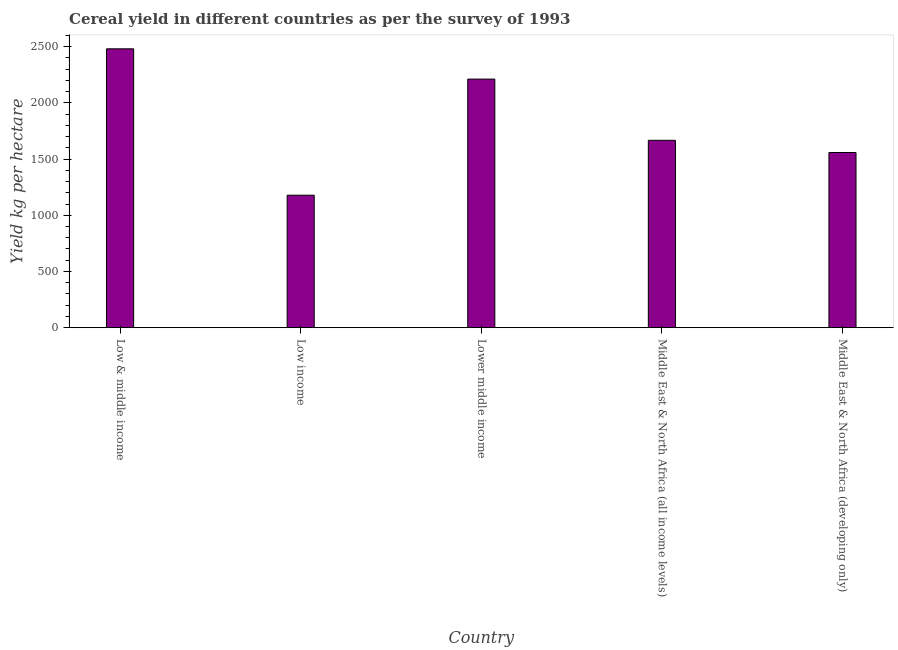What is the title of the graph?
Provide a succinct answer. Cereal yield in different countries as per the survey of 1993. What is the label or title of the X-axis?
Ensure brevity in your answer.  Country. What is the label or title of the Y-axis?
Provide a short and direct response. Yield kg per hectare. What is the cereal yield in Middle East & North Africa (all income levels)?
Ensure brevity in your answer.  1667.12. Across all countries, what is the maximum cereal yield?
Make the answer very short. 2481.08. Across all countries, what is the minimum cereal yield?
Offer a very short reply. 1178.62. What is the sum of the cereal yield?
Ensure brevity in your answer.  9097.02. What is the difference between the cereal yield in Lower middle income and Middle East & North Africa (all income levels)?
Your response must be concise. 544.64. What is the average cereal yield per country?
Offer a very short reply. 1819.4. What is the median cereal yield?
Keep it short and to the point. 1667.12. What is the ratio of the cereal yield in Lower middle income to that in Middle East & North Africa (developing only)?
Provide a short and direct response. 1.42. Is the difference between the cereal yield in Lower middle income and Middle East & North Africa (developing only) greater than the difference between any two countries?
Offer a very short reply. No. What is the difference between the highest and the second highest cereal yield?
Make the answer very short. 269.32. What is the difference between the highest and the lowest cereal yield?
Your answer should be very brief. 1302.46. In how many countries, is the cereal yield greater than the average cereal yield taken over all countries?
Keep it short and to the point. 2. Are all the bars in the graph horizontal?
Provide a succinct answer. No. What is the difference between two consecutive major ticks on the Y-axis?
Provide a succinct answer. 500. What is the Yield kg per hectare of Low & middle income?
Provide a short and direct response. 2481.08. What is the Yield kg per hectare of Low income?
Offer a terse response. 1178.62. What is the Yield kg per hectare of Lower middle income?
Ensure brevity in your answer.  2211.76. What is the Yield kg per hectare of Middle East & North Africa (all income levels)?
Your answer should be very brief. 1667.12. What is the Yield kg per hectare in Middle East & North Africa (developing only)?
Ensure brevity in your answer.  1558.43. What is the difference between the Yield kg per hectare in Low & middle income and Low income?
Offer a terse response. 1302.46. What is the difference between the Yield kg per hectare in Low & middle income and Lower middle income?
Your answer should be very brief. 269.33. What is the difference between the Yield kg per hectare in Low & middle income and Middle East & North Africa (all income levels)?
Your answer should be very brief. 813.97. What is the difference between the Yield kg per hectare in Low & middle income and Middle East & North Africa (developing only)?
Your answer should be compact. 922.65. What is the difference between the Yield kg per hectare in Low income and Lower middle income?
Your answer should be very brief. -1033.14. What is the difference between the Yield kg per hectare in Low income and Middle East & North Africa (all income levels)?
Your answer should be very brief. -488.5. What is the difference between the Yield kg per hectare in Low income and Middle East & North Africa (developing only)?
Your answer should be compact. -379.81. What is the difference between the Yield kg per hectare in Lower middle income and Middle East & North Africa (all income levels)?
Provide a succinct answer. 544.64. What is the difference between the Yield kg per hectare in Lower middle income and Middle East & North Africa (developing only)?
Make the answer very short. 653.33. What is the difference between the Yield kg per hectare in Middle East & North Africa (all income levels) and Middle East & North Africa (developing only)?
Your answer should be very brief. 108.69. What is the ratio of the Yield kg per hectare in Low & middle income to that in Low income?
Your response must be concise. 2.1. What is the ratio of the Yield kg per hectare in Low & middle income to that in Lower middle income?
Provide a short and direct response. 1.12. What is the ratio of the Yield kg per hectare in Low & middle income to that in Middle East & North Africa (all income levels)?
Your answer should be very brief. 1.49. What is the ratio of the Yield kg per hectare in Low & middle income to that in Middle East & North Africa (developing only)?
Provide a succinct answer. 1.59. What is the ratio of the Yield kg per hectare in Low income to that in Lower middle income?
Your response must be concise. 0.53. What is the ratio of the Yield kg per hectare in Low income to that in Middle East & North Africa (all income levels)?
Offer a very short reply. 0.71. What is the ratio of the Yield kg per hectare in Low income to that in Middle East & North Africa (developing only)?
Your answer should be very brief. 0.76. What is the ratio of the Yield kg per hectare in Lower middle income to that in Middle East & North Africa (all income levels)?
Make the answer very short. 1.33. What is the ratio of the Yield kg per hectare in Lower middle income to that in Middle East & North Africa (developing only)?
Provide a succinct answer. 1.42. What is the ratio of the Yield kg per hectare in Middle East & North Africa (all income levels) to that in Middle East & North Africa (developing only)?
Give a very brief answer. 1.07. 